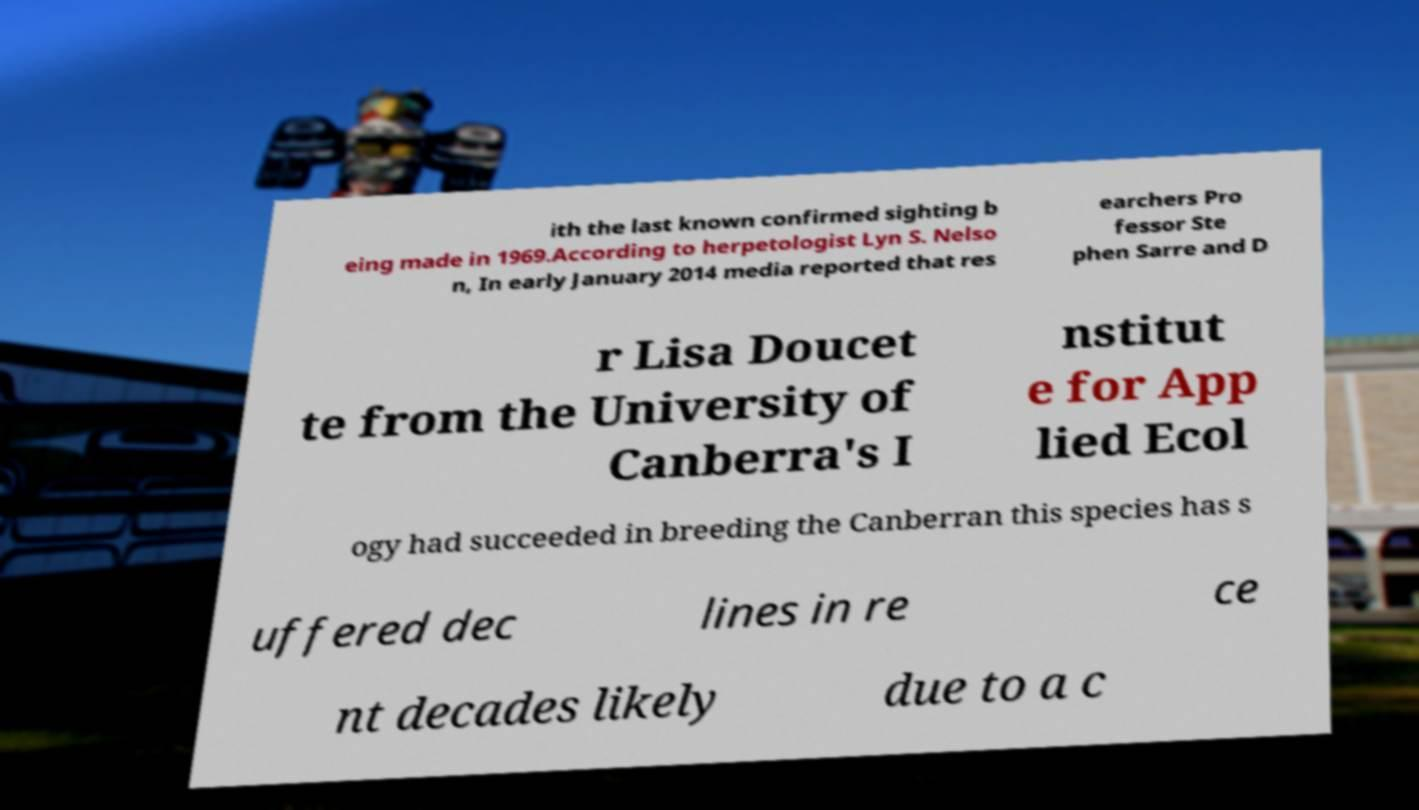There's text embedded in this image that I need extracted. Can you transcribe it verbatim? ith the last known confirmed sighting b eing made in 1969.According to herpetologist Lyn S. Nelso n, In early January 2014 media reported that res earchers Pro fessor Ste phen Sarre and D r Lisa Doucet te from the University of Canberra's I nstitut e for App lied Ecol ogy had succeeded in breeding the Canberran this species has s uffered dec lines in re ce nt decades likely due to a c 